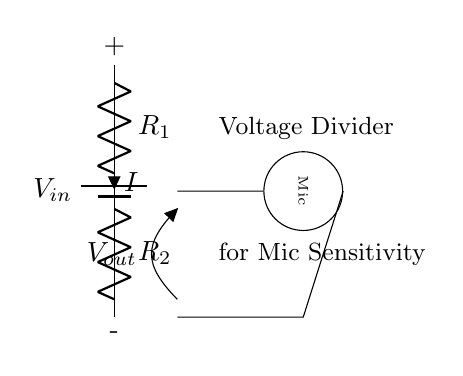What type of circuit is this? This circuit is a voltage divider circuit, which is indicated by the two resistors connected in series between the input voltage and ground. The purpose is to create a reduced output voltage for the microphone.
Answer: voltage divider circuit What are the components in this circuit? The components are a battery, two resistors, and a microphone. The battery provides input voltage, while the resistors form the divider to adjust the voltage for the mic.
Answer: battery, resistors, microphone What is the symbol used for the microphone? The symbol for the microphone is a circle with a label inside that says "Mic." The orientation indicates that it is a microphone.
Answer: circle with "Mic" What does "Vout" represent in this circuit? "Vout" represents the output voltage that is delivered to the microphone, which is derived from the input voltage divided by the resistor values.
Answer: output voltage What current flows through the higher resistor, R1? The current (I) that flows through R1 is the same as the current flowing through R2 in a series circuit. It's common for both resistors, described as I in the diagram.
Answer: I How is the output voltage related to the resistor values? The output voltage, "Vout," is determined by the formula Vout = Vin * (R2 / (R1 + R2)), where Vin is the input voltage and R1 and R2 are the resistances. This shows that R2 plays a crucial role in determining "Vout."
Answer: Vout = Vin * (R2 / (R1 + R2)) What is the primary purpose of this circuit? The primary purpose of this circuit is to adjust microphone sensitivity by providing a suitable voltage level to the microphone. This helps ensure proper signal levels for the microphone's operation.
Answer: adjust microphone sensitivity 